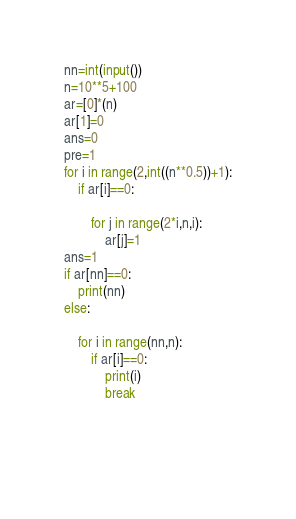<code> <loc_0><loc_0><loc_500><loc_500><_Python_>nn=int(input())
n=10**5+100
ar=[0]*(n)
ar[1]=0
ans=0
pre=1
for i in range(2,int((n**0.5))+1):
    if ar[i]==0:

        for j in range(2*i,n,i):
            ar[j]=1
ans=1
if ar[nn]==0:
    print(nn)
else:
        
    for i in range(nn,n):
        if ar[i]==0:
            print(i)
            break
        

        </code> 